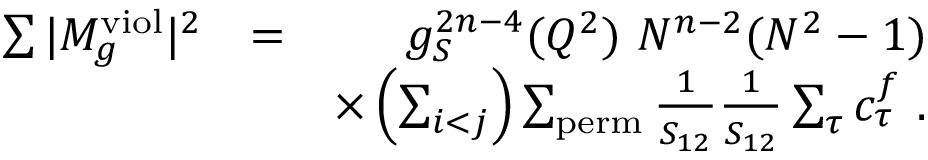Convert formula to latex. <formula><loc_0><loc_0><loc_500><loc_500>\begin{array} { r l r } { \sum | M _ { g } ^ { v i o l } | ^ { 2 } } & { = } & { g _ { S } ^ { 2 n - 4 } ( Q ^ { 2 } ) N ^ { n - 2 } ( N ^ { 2 } - 1 ) } \\ & { \times \left ( \sum _ { i < j } \right ) \sum _ { p e r m } \frac { 1 } { S _ { 1 2 } } \frac { 1 } { S _ { 1 2 } } \sum _ { \tau } c _ { \tau } ^ { f } . } \end{array}</formula> 